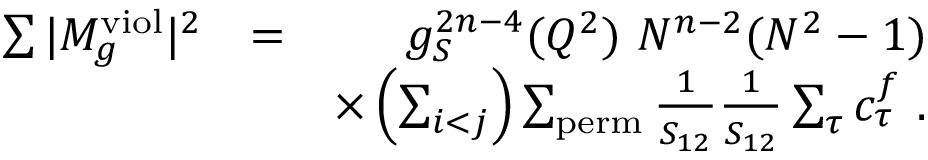Convert formula to latex. <formula><loc_0><loc_0><loc_500><loc_500>\begin{array} { r l r } { \sum | M _ { g } ^ { v i o l } | ^ { 2 } } & { = } & { g _ { S } ^ { 2 n - 4 } ( Q ^ { 2 } ) N ^ { n - 2 } ( N ^ { 2 } - 1 ) } \\ & { \times \left ( \sum _ { i < j } \right ) \sum _ { p e r m } \frac { 1 } { S _ { 1 2 } } \frac { 1 } { S _ { 1 2 } } \sum _ { \tau } c _ { \tau } ^ { f } . } \end{array}</formula> 